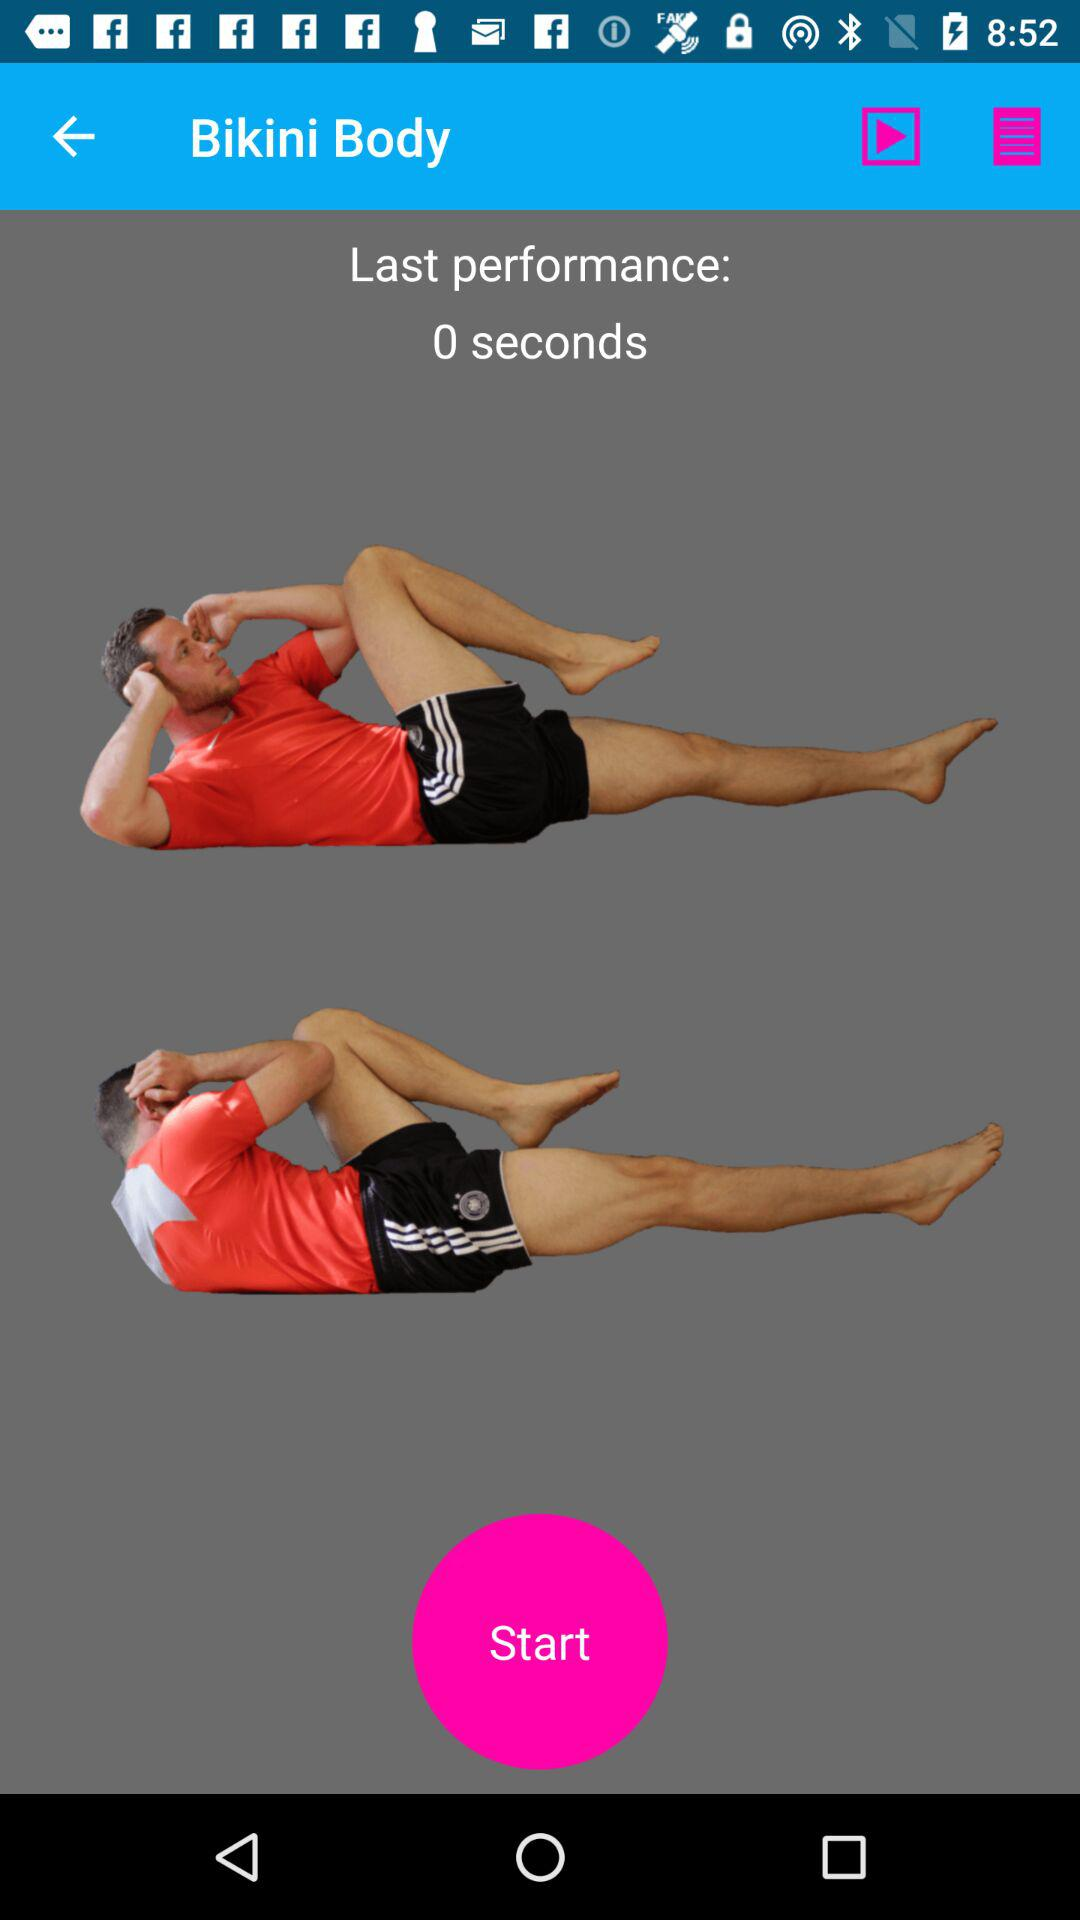How long was the last performance? The last performance was 0 seconds long. 